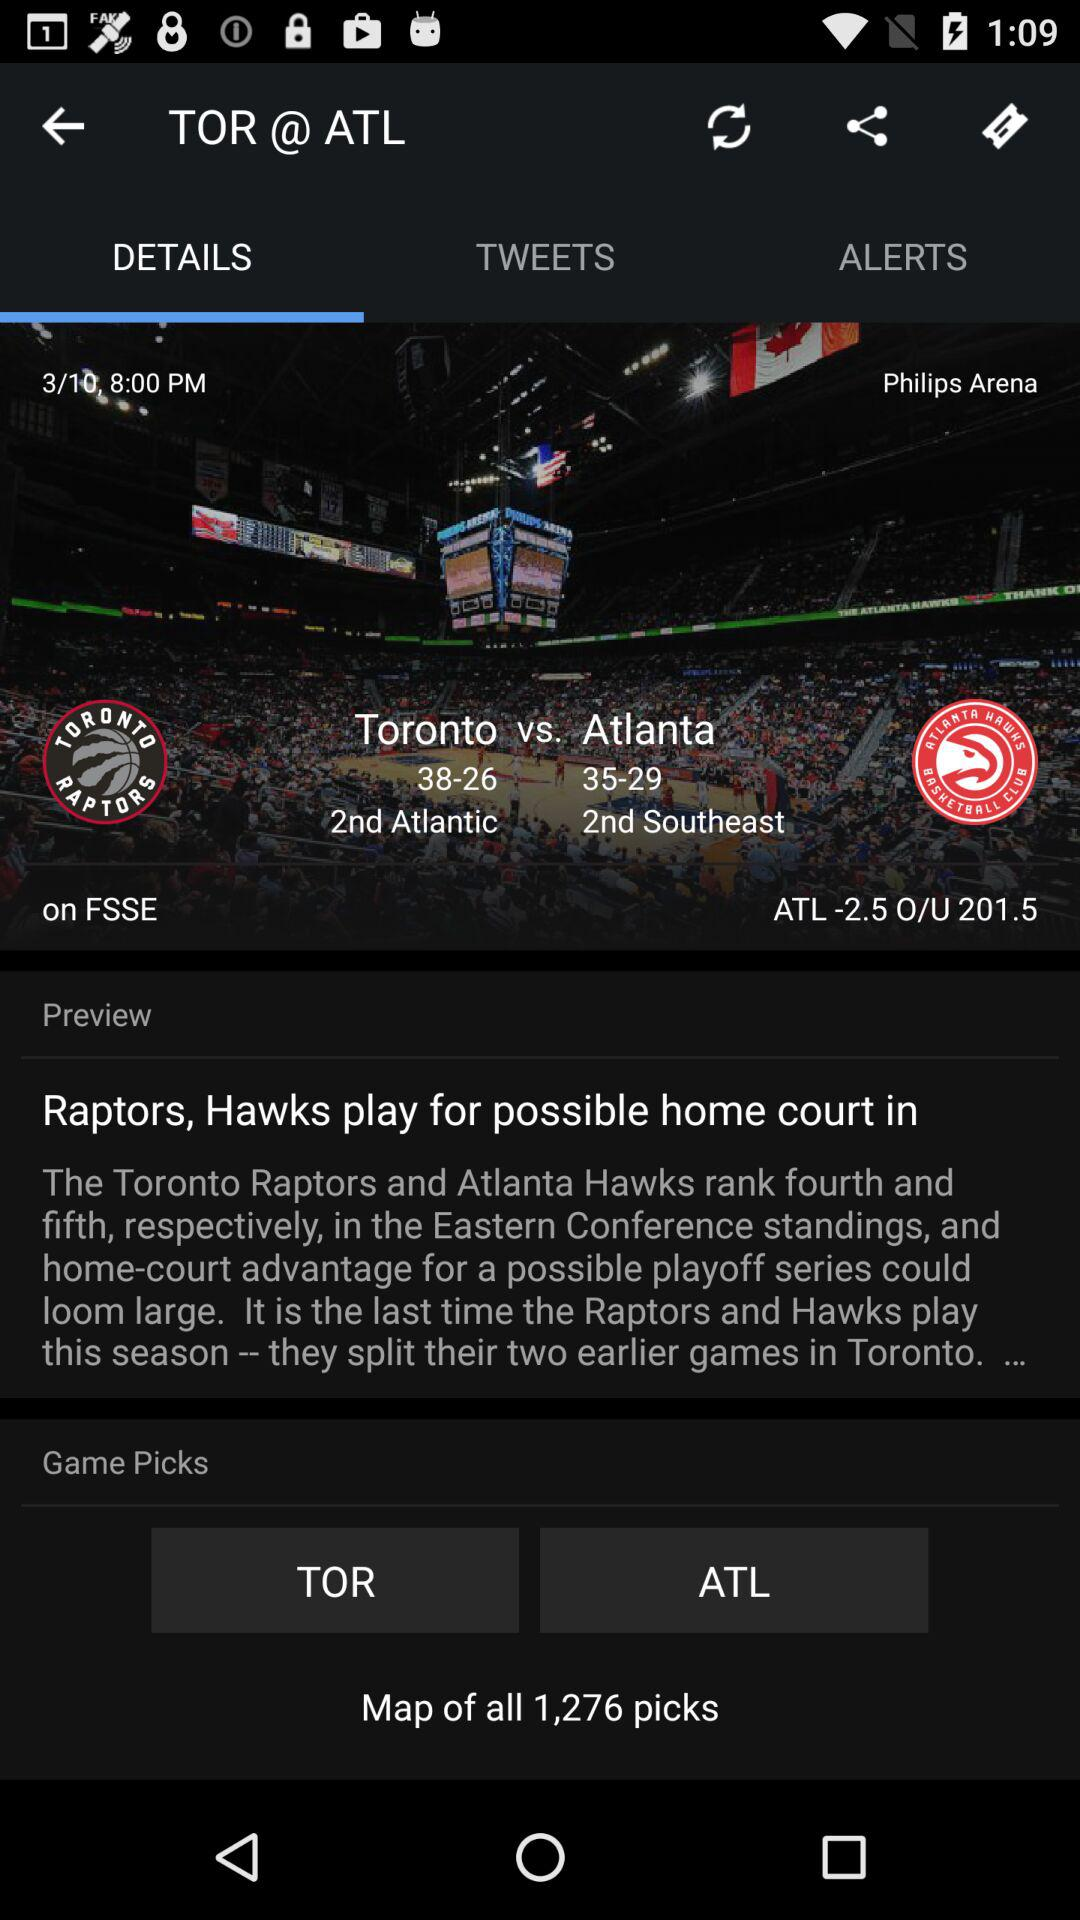What is the total number of picks? The total number of picks is 1,276. 